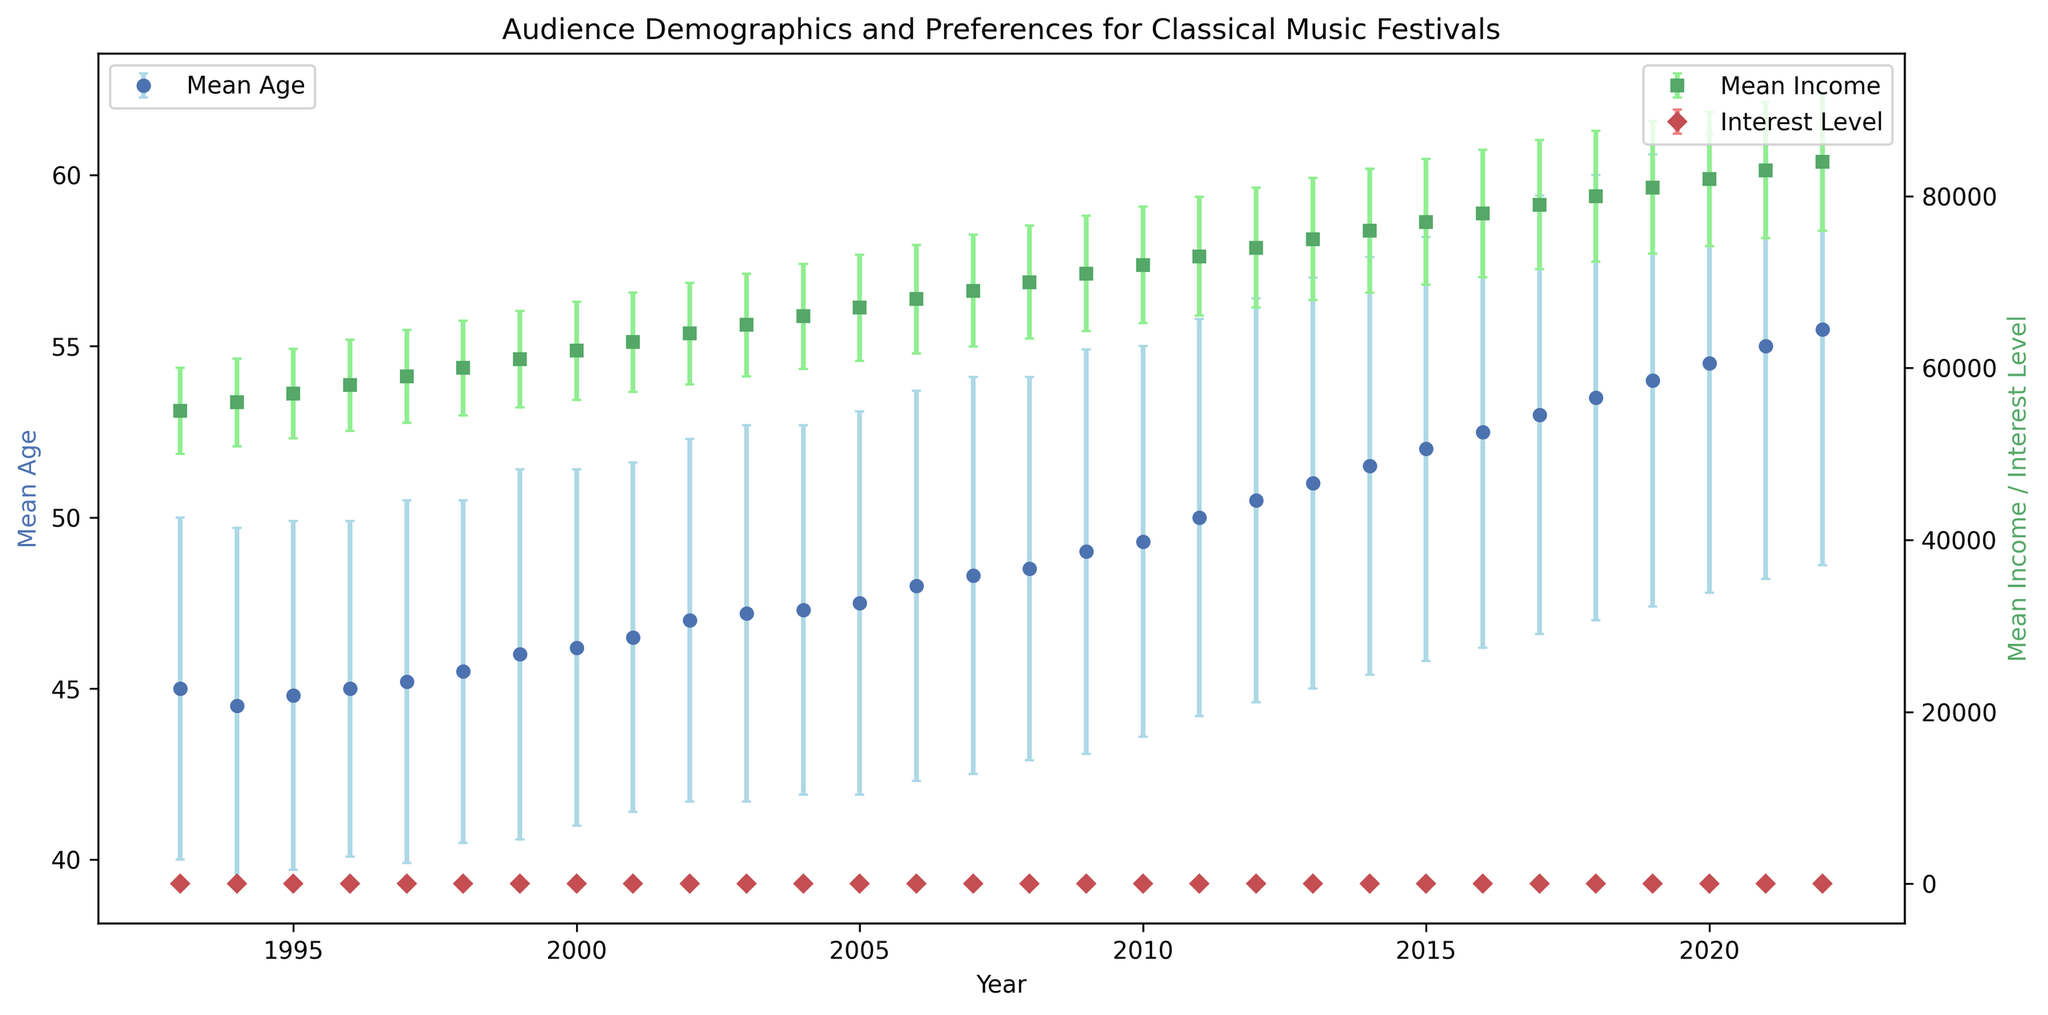What is the trend in the mean age of the audience from 1993 to 2022? The plot shows an increasing trend in mean age over the years from 1993 to 2022, reflecting aging demographics.
Answer: Increasing What was the mean income of the audience in the year 2000? According to the plotted data, the mean income in the year 2000 is labeled, and you can directly read the value off the plot.
Answer: 62000 How does the interest level change between 2010 and 2022? The interest level increases from around 4.8 in 2010 to about 5.9 in 2022, reflecting a growing interest in classical music festivals over time.
Answer: Increasing Which year shows the highest interest level mean? From the data points with the highest interest level markers in red, the year 2022 shows the highest interest level mean.
Answer: 2022 Did female percentage increase or decrease from 1993 to 2022? By comparing the initial and final years, we see that the percentage of females in the audience increased from 53% in 1993 to 58% in 2022.
Answer: Increase What are the trends in mean income and interest level from 1993 to 2022? Both mean income and interest level show a general upward trend over the years, indicating economic growth and increasing interest in classical music festivals.
Answer: Economic growth, increasing interest In which year did the mean age approximately reach 50 for the first time? By identifying the year where the blue error bars' midpoint reaches the 50-mark on the plot, it is around the year 2011.
Answer: 2011 What was the male percentage in 2010? According to the plot, the male percentage for each year can be seen, and for 2010, it is about 48%.
Answer: 48% Between 1993 and 2022, in which year was the mean income closest to 70000? By comparing plotted income values, in the year 2008, the mean income is closest to 70000.
Answer: 2008 How does the variability in age (measured by the error bars) change from 1993 to 2022? Evaluating the vertical lengths of blue error bars, the variability (standard deviation) in age slightly increases over the years.
Answer: Slightly increasing 